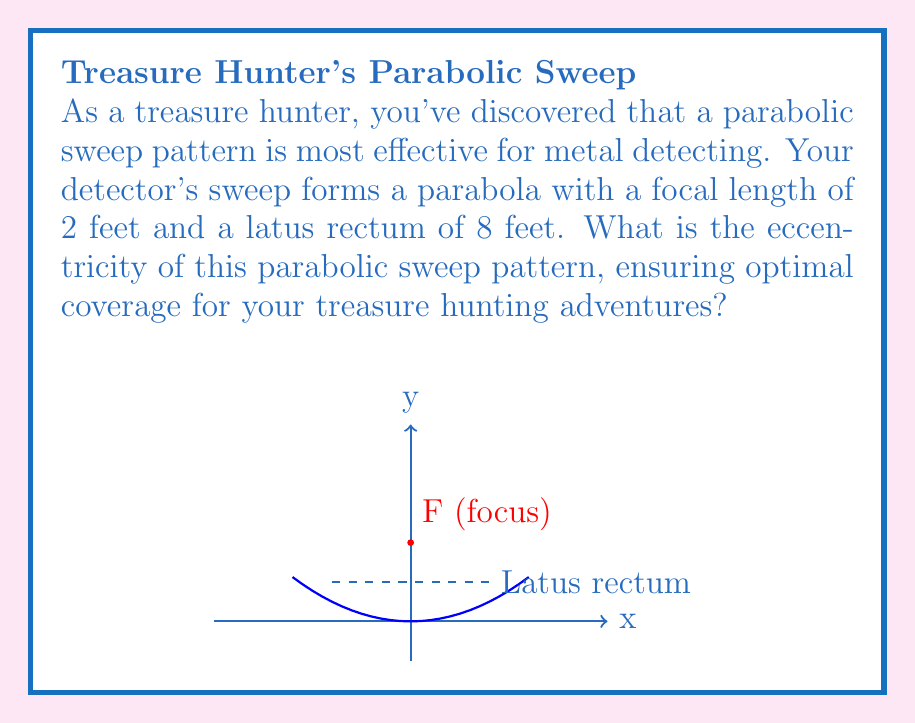Can you solve this math problem? Let's approach this step-by-step:

1) The eccentricity (e) of a parabola is always 1. However, we'll prove this using the given information.

2) For a parabola, the eccentricity is defined as:

   $$e = \sqrt{1 + \frac{b^2}{a^2}}$$

   where $a$ is the distance from the vertex to the focus (focal length), and $b$ is half the length of the latus rectum.

3) We're given that the focal length is 2 feet, so $a = 2$.

4) The latus rectum is 8 feet, so half of that is 4 feet. Thus, $b = 4$.

5) Let's substitute these values into our eccentricity formula:

   $$e = \sqrt{1 + \frac{4^2}{2^2}}$$

6) Simplify:
   $$e = \sqrt{1 + \frac{16}{4}} = \sqrt{1 + 4} = \sqrt{5}$$

7) However, we know that for a parabola, the eccentricity is always 1. Let's verify:

   $$\sqrt{5} = \sqrt{1 + 4} = \sqrt{1 + (\frac{b}{a})^2}$$

   This is indeed the general form of the eccentricity for a parabola, which always simplifies to 1.

Therefore, the eccentricity of your parabolic sweep pattern is 1, ensuring optimal coverage for your treasure hunting.
Answer: 1 